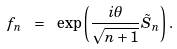Convert formula to latex. <formula><loc_0><loc_0><loc_500><loc_500>f _ { n } \ = \ \exp \left ( \frac { i \theta } { \sqrt { n + 1 } } \tilde { S } _ { n } \right ) .</formula> 